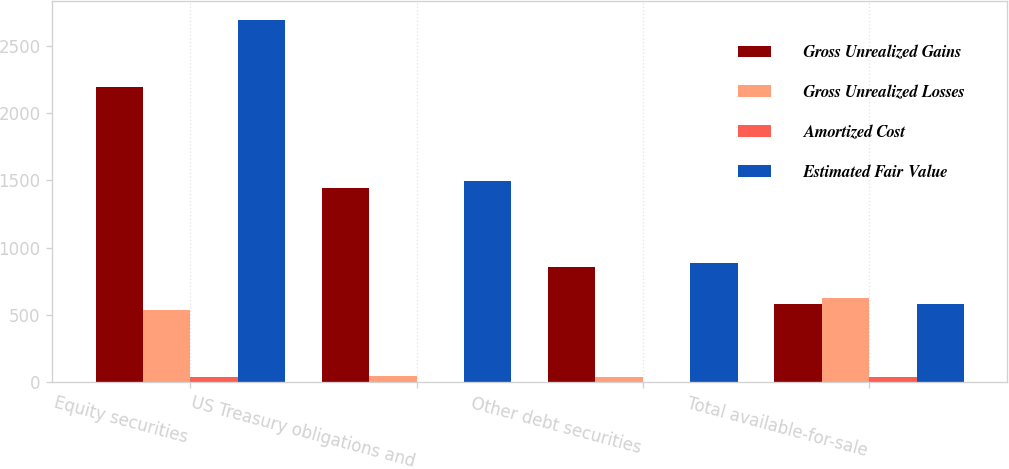Convert chart. <chart><loc_0><loc_0><loc_500><loc_500><stacked_bar_chart><ecel><fcel>Equity securities<fcel>US Treasury obligations and<fcel>Other debt securities<fcel>Total available-for-sale<nl><fcel>Gross Unrealized Gains<fcel>2194<fcel>1447<fcel>855<fcel>582<nl><fcel>Gross Unrealized Losses<fcel>538<fcel>51<fcel>37<fcel>626<nl><fcel>Amortized Cost<fcel>37<fcel>4<fcel>3<fcel>44<nl><fcel>Estimated Fair Value<fcel>2695<fcel>1494<fcel>889<fcel>582<nl></chart> 